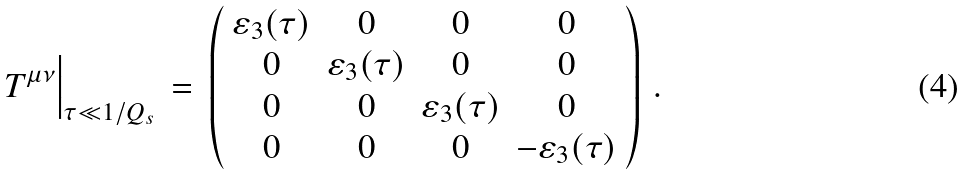<formula> <loc_0><loc_0><loc_500><loc_500>T ^ { \mu \nu } \Big | _ { \tau \ll 1 / Q _ { s } } \, = \, \left ( \begin{array} { c c c c } \varepsilon _ { 3 } ( \tau ) & 0 & 0 & 0 \\ 0 & \varepsilon _ { 3 } ( \tau ) & 0 & 0 \\ 0 & 0 & \varepsilon _ { 3 } ( \tau ) & 0 \\ 0 & 0 & 0 & - \varepsilon _ { 3 } ( \tau ) \end{array} \right ) \, .</formula> 